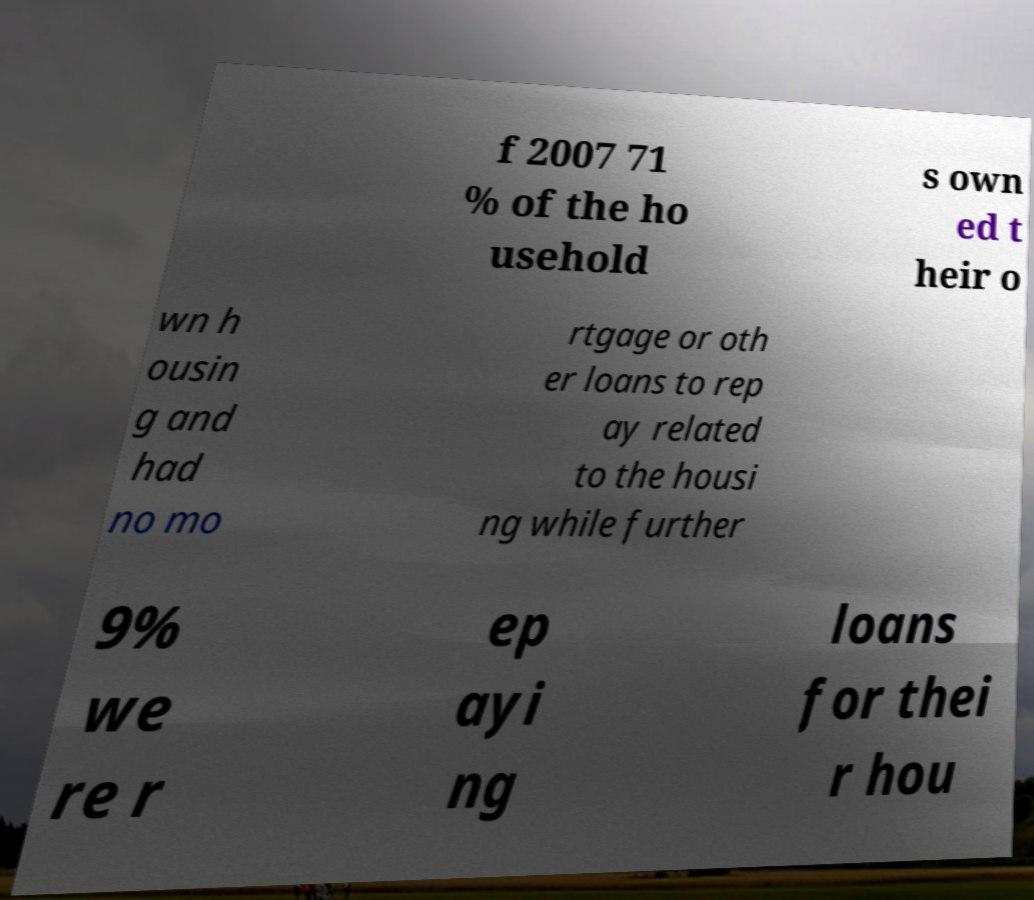I need the written content from this picture converted into text. Can you do that? f 2007 71 % of the ho usehold s own ed t heir o wn h ousin g and had no mo rtgage or oth er loans to rep ay related to the housi ng while further 9% we re r ep ayi ng loans for thei r hou 